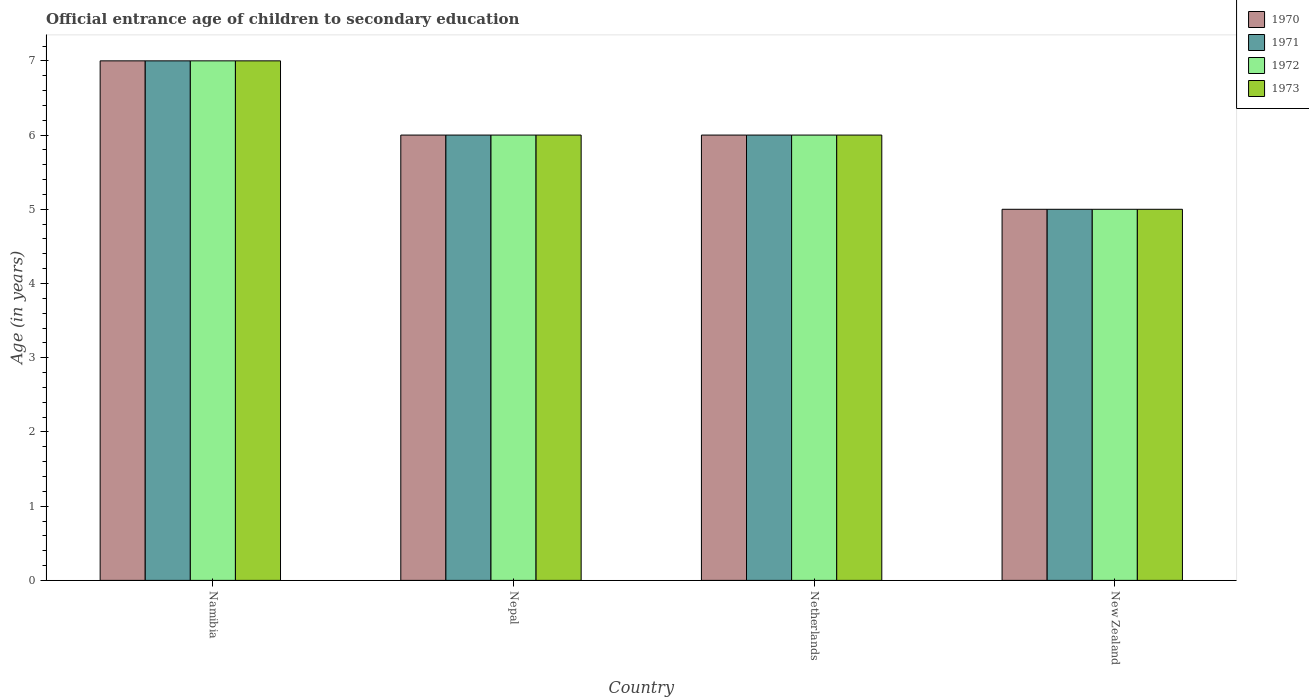How many groups of bars are there?
Make the answer very short. 4. What is the label of the 1st group of bars from the left?
Provide a short and direct response. Namibia. Across all countries, what is the maximum secondary school starting age of children in 1972?
Keep it short and to the point. 7. In which country was the secondary school starting age of children in 1972 maximum?
Provide a succinct answer. Namibia. In which country was the secondary school starting age of children in 1971 minimum?
Offer a terse response. New Zealand. What is the total secondary school starting age of children in 1972 in the graph?
Keep it short and to the point. 24. What is the difference between the secondary school starting age of children in 1973 in Nepal and that in New Zealand?
Make the answer very short. 1. What is the average secondary school starting age of children in 1971 per country?
Ensure brevity in your answer.  6. What is the difference between the secondary school starting age of children of/in 1971 and secondary school starting age of children of/in 1970 in Netherlands?
Provide a short and direct response. 0. In how many countries, is the secondary school starting age of children in 1970 greater than the average secondary school starting age of children in 1970 taken over all countries?
Make the answer very short. 1. Is the sum of the secondary school starting age of children in 1970 in Nepal and Netherlands greater than the maximum secondary school starting age of children in 1973 across all countries?
Provide a short and direct response. Yes. Is it the case that in every country, the sum of the secondary school starting age of children in 1973 and secondary school starting age of children in 1972 is greater than the sum of secondary school starting age of children in 1971 and secondary school starting age of children in 1970?
Ensure brevity in your answer.  No. Is it the case that in every country, the sum of the secondary school starting age of children in 1970 and secondary school starting age of children in 1972 is greater than the secondary school starting age of children in 1973?
Make the answer very short. Yes. Are all the bars in the graph horizontal?
Offer a very short reply. No. Are the values on the major ticks of Y-axis written in scientific E-notation?
Your answer should be very brief. No. Where does the legend appear in the graph?
Provide a short and direct response. Top right. How are the legend labels stacked?
Provide a short and direct response. Vertical. What is the title of the graph?
Ensure brevity in your answer.  Official entrance age of children to secondary education. What is the label or title of the Y-axis?
Your response must be concise. Age (in years). What is the Age (in years) in 1971 in Namibia?
Offer a terse response. 7. What is the Age (in years) of 1973 in Namibia?
Provide a short and direct response. 7. What is the Age (in years) in 1970 in Nepal?
Offer a very short reply. 6. What is the Age (in years) of 1972 in Nepal?
Keep it short and to the point. 6. What is the Age (in years) in 1973 in Nepal?
Offer a very short reply. 6. What is the Age (in years) of 1970 in Netherlands?
Offer a terse response. 6. What is the Age (in years) in 1972 in Netherlands?
Keep it short and to the point. 6. What is the Age (in years) in 1973 in Netherlands?
Your answer should be very brief. 6. Across all countries, what is the maximum Age (in years) of 1970?
Give a very brief answer. 7. Across all countries, what is the maximum Age (in years) in 1972?
Give a very brief answer. 7. Across all countries, what is the minimum Age (in years) of 1972?
Offer a terse response. 5. Across all countries, what is the minimum Age (in years) in 1973?
Your answer should be very brief. 5. What is the total Age (in years) in 1971 in the graph?
Your answer should be compact. 24. What is the total Age (in years) in 1972 in the graph?
Offer a terse response. 24. What is the total Age (in years) of 1973 in the graph?
Offer a very short reply. 24. What is the difference between the Age (in years) of 1971 in Namibia and that in Nepal?
Provide a short and direct response. 1. What is the difference between the Age (in years) of 1972 in Namibia and that in Nepal?
Your answer should be compact. 1. What is the difference between the Age (in years) of 1973 in Namibia and that in Nepal?
Offer a very short reply. 1. What is the difference between the Age (in years) in 1971 in Namibia and that in Netherlands?
Offer a terse response. 1. What is the difference between the Age (in years) of 1970 in Namibia and that in New Zealand?
Give a very brief answer. 2. What is the difference between the Age (in years) in 1971 in Namibia and that in New Zealand?
Provide a succinct answer. 2. What is the difference between the Age (in years) of 1970 in Nepal and that in Netherlands?
Ensure brevity in your answer.  0. What is the difference between the Age (in years) in 1971 in Nepal and that in Netherlands?
Provide a succinct answer. 0. What is the difference between the Age (in years) of 1972 in Nepal and that in Netherlands?
Offer a terse response. 0. What is the difference between the Age (in years) of 1970 in Nepal and that in New Zealand?
Provide a succinct answer. 1. What is the difference between the Age (in years) of 1973 in Nepal and that in New Zealand?
Make the answer very short. 1. What is the difference between the Age (in years) in 1970 in Netherlands and that in New Zealand?
Offer a very short reply. 1. What is the difference between the Age (in years) of 1972 in Netherlands and that in New Zealand?
Offer a very short reply. 1. What is the difference between the Age (in years) in 1973 in Netherlands and that in New Zealand?
Your answer should be compact. 1. What is the difference between the Age (in years) of 1970 in Namibia and the Age (in years) of 1972 in Nepal?
Keep it short and to the point. 1. What is the difference between the Age (in years) of 1971 in Namibia and the Age (in years) of 1973 in Nepal?
Your response must be concise. 1. What is the difference between the Age (in years) in 1970 in Namibia and the Age (in years) in 1971 in Netherlands?
Keep it short and to the point. 1. What is the difference between the Age (in years) of 1970 in Namibia and the Age (in years) of 1973 in Netherlands?
Ensure brevity in your answer.  1. What is the difference between the Age (in years) of 1971 in Namibia and the Age (in years) of 1973 in Netherlands?
Ensure brevity in your answer.  1. What is the difference between the Age (in years) of 1972 in Namibia and the Age (in years) of 1973 in Netherlands?
Your answer should be very brief. 1. What is the difference between the Age (in years) in 1970 in Namibia and the Age (in years) in 1971 in New Zealand?
Your answer should be very brief. 2. What is the difference between the Age (in years) in 1970 in Namibia and the Age (in years) in 1972 in New Zealand?
Offer a terse response. 2. What is the difference between the Age (in years) of 1970 in Namibia and the Age (in years) of 1973 in New Zealand?
Offer a very short reply. 2. What is the difference between the Age (in years) in 1970 in Nepal and the Age (in years) in 1971 in Netherlands?
Make the answer very short. 0. What is the difference between the Age (in years) in 1970 in Nepal and the Age (in years) in 1972 in Netherlands?
Keep it short and to the point. 0. What is the difference between the Age (in years) of 1970 in Nepal and the Age (in years) of 1973 in Netherlands?
Your answer should be very brief. 0. What is the difference between the Age (in years) in 1971 in Nepal and the Age (in years) in 1973 in Netherlands?
Give a very brief answer. 0. What is the difference between the Age (in years) in 1972 in Nepal and the Age (in years) in 1973 in Netherlands?
Keep it short and to the point. 0. What is the difference between the Age (in years) of 1971 in Nepal and the Age (in years) of 1973 in New Zealand?
Offer a very short reply. 1. What is the difference between the Age (in years) of 1972 in Nepal and the Age (in years) of 1973 in New Zealand?
Provide a short and direct response. 1. What is the difference between the Age (in years) in 1970 in Netherlands and the Age (in years) in 1972 in New Zealand?
Your response must be concise. 1. What is the difference between the Age (in years) in 1972 in Netherlands and the Age (in years) in 1973 in New Zealand?
Your answer should be very brief. 1. What is the average Age (in years) of 1973 per country?
Your answer should be compact. 6. What is the difference between the Age (in years) in 1970 and Age (in years) in 1971 in Namibia?
Ensure brevity in your answer.  0. What is the difference between the Age (in years) of 1970 and Age (in years) of 1972 in Namibia?
Keep it short and to the point. 0. What is the difference between the Age (in years) in 1970 and Age (in years) in 1973 in Namibia?
Ensure brevity in your answer.  0. What is the difference between the Age (in years) in 1971 and Age (in years) in 1972 in Namibia?
Your answer should be compact. 0. What is the difference between the Age (in years) of 1971 and Age (in years) of 1973 in Namibia?
Provide a succinct answer. 0. What is the difference between the Age (in years) of 1972 and Age (in years) of 1973 in Namibia?
Your response must be concise. 0. What is the difference between the Age (in years) of 1971 and Age (in years) of 1972 in Nepal?
Offer a terse response. 0. What is the difference between the Age (in years) of 1972 and Age (in years) of 1973 in Nepal?
Ensure brevity in your answer.  0. What is the difference between the Age (in years) in 1970 and Age (in years) in 1971 in Netherlands?
Keep it short and to the point. 0. What is the difference between the Age (in years) of 1970 and Age (in years) of 1972 in Netherlands?
Your answer should be compact. 0. What is the difference between the Age (in years) of 1970 and Age (in years) of 1973 in Netherlands?
Make the answer very short. 0. What is the difference between the Age (in years) in 1971 and Age (in years) in 1972 in Netherlands?
Your response must be concise. 0. What is the difference between the Age (in years) in 1970 and Age (in years) in 1971 in New Zealand?
Your answer should be compact. 0. What is the difference between the Age (in years) in 1972 and Age (in years) in 1973 in New Zealand?
Ensure brevity in your answer.  0. What is the ratio of the Age (in years) in 1970 in Namibia to that in Nepal?
Ensure brevity in your answer.  1.17. What is the ratio of the Age (in years) of 1971 in Namibia to that in Nepal?
Keep it short and to the point. 1.17. What is the ratio of the Age (in years) in 1970 in Namibia to that in Netherlands?
Provide a succinct answer. 1.17. What is the ratio of the Age (in years) of 1971 in Namibia to that in Netherlands?
Provide a succinct answer. 1.17. What is the ratio of the Age (in years) of 1972 in Namibia to that in Netherlands?
Ensure brevity in your answer.  1.17. What is the ratio of the Age (in years) of 1973 in Namibia to that in Netherlands?
Ensure brevity in your answer.  1.17. What is the ratio of the Age (in years) in 1973 in Namibia to that in New Zealand?
Provide a succinct answer. 1.4. What is the ratio of the Age (in years) in 1970 in Nepal to that in Netherlands?
Ensure brevity in your answer.  1. What is the ratio of the Age (in years) of 1972 in Nepal to that in Netherlands?
Provide a succinct answer. 1. What is the ratio of the Age (in years) of 1973 in Nepal to that in Netherlands?
Provide a succinct answer. 1. What is the ratio of the Age (in years) of 1970 in Nepal to that in New Zealand?
Give a very brief answer. 1.2. What is the ratio of the Age (in years) of 1971 in Nepal to that in New Zealand?
Ensure brevity in your answer.  1.2. What is the ratio of the Age (in years) in 1971 in Netherlands to that in New Zealand?
Your response must be concise. 1.2. What is the difference between the highest and the second highest Age (in years) of 1970?
Keep it short and to the point. 1. What is the difference between the highest and the second highest Age (in years) in 1971?
Ensure brevity in your answer.  1. What is the difference between the highest and the lowest Age (in years) in 1971?
Offer a terse response. 2. What is the difference between the highest and the lowest Age (in years) of 1972?
Provide a short and direct response. 2. What is the difference between the highest and the lowest Age (in years) of 1973?
Keep it short and to the point. 2. 